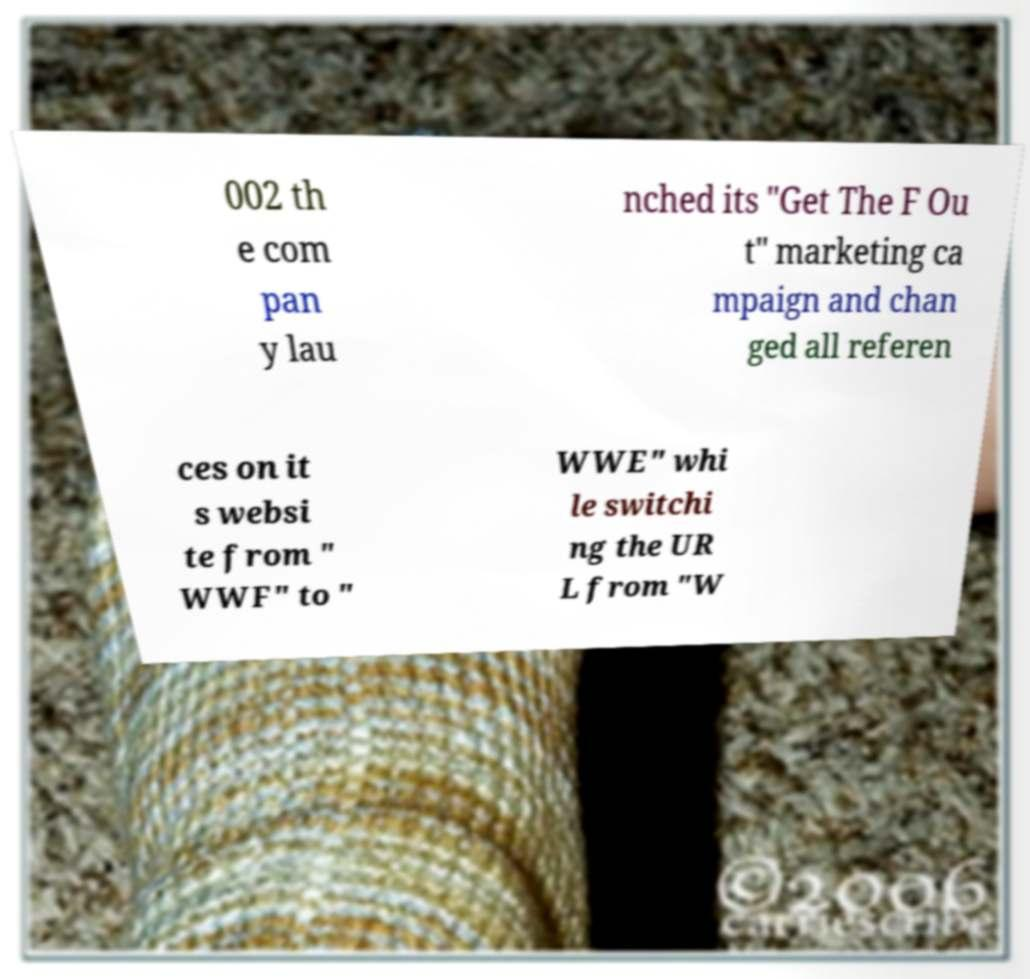Please read and relay the text visible in this image. What does it say? 002 th e com pan y lau nched its "Get The F Ou t" marketing ca mpaign and chan ged all referen ces on it s websi te from " WWF" to " WWE" whi le switchi ng the UR L from "W 